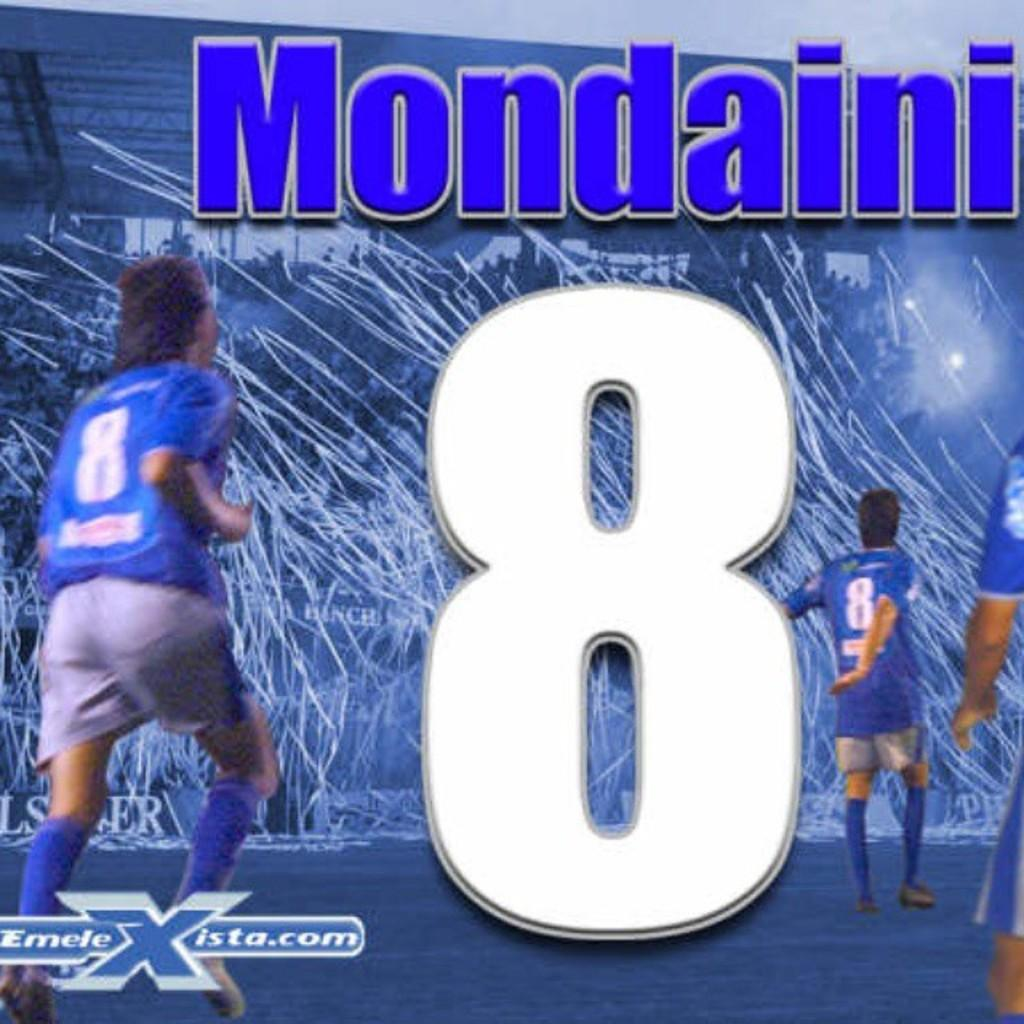<image>
Offer a succinct explanation of the picture presented. an ad with the number 8 on it and Mondaini 